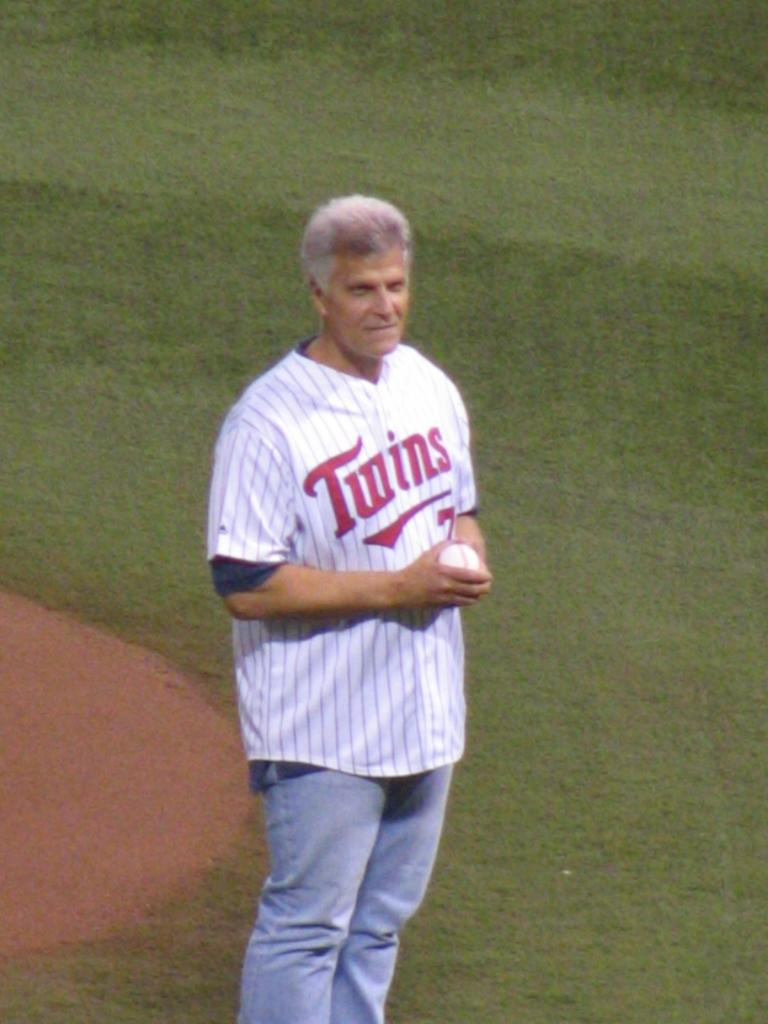<image>
Render a clear and concise summary of the photo. A man stading on a field wearing a Twins shirt. 